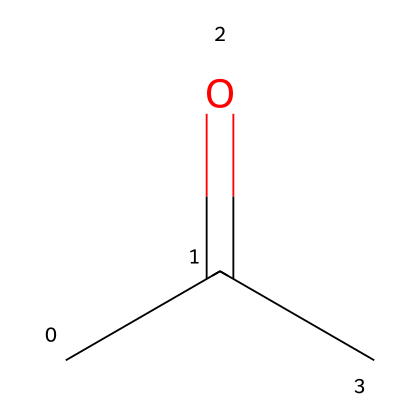What is the name of this chemical? The SMILES representation indicates the structure of the chemical, which corresponds to acetone, a well-known solvent.
Answer: acetone How many carbon atoms are in this molecule? By analyzing the SMILES, we can see two carbon atoms in the chain ("CC") and one carbon in the carbonyl group ("C=O"), totaling three carbon atoms.
Answer: three What type of functional group does acetone contain? The structure shows a carbonyl group (C=O) as it is part of the functional group defining ketones, specifically noted by the position between two carbon atoms in acetone.
Answer: ketone What is the total number of hydrogen atoms in acetone? Each carbon in acetone is bonded to enough hydrogen atoms to satisfy carbon's tetravalent nature. Here, there are six hydrogen atoms connected to three carbons.
Answer: six Is acetone considered a flammable liquid? Acetone's molecular structure, containing volatile compounds, and its known properties categorize it as a flammable liquid.
Answer: yes What is the molecular weight of acetone? Acetone's molecular formula (C3H6O) provides the molecular weight by summing the weights of its constituent atoms: (3*12.01 + 6*1.008 + 16.00 g/mol).
Answer: 58.08 g/mol What safety precautions should be taken when handling acetone? Due to its flammability and potential health risks, handling acetone requires precautions such as using it in well-ventilated areas, wearing gloves, and avoiding ignition sources.
Answer: ventilation, gloves 